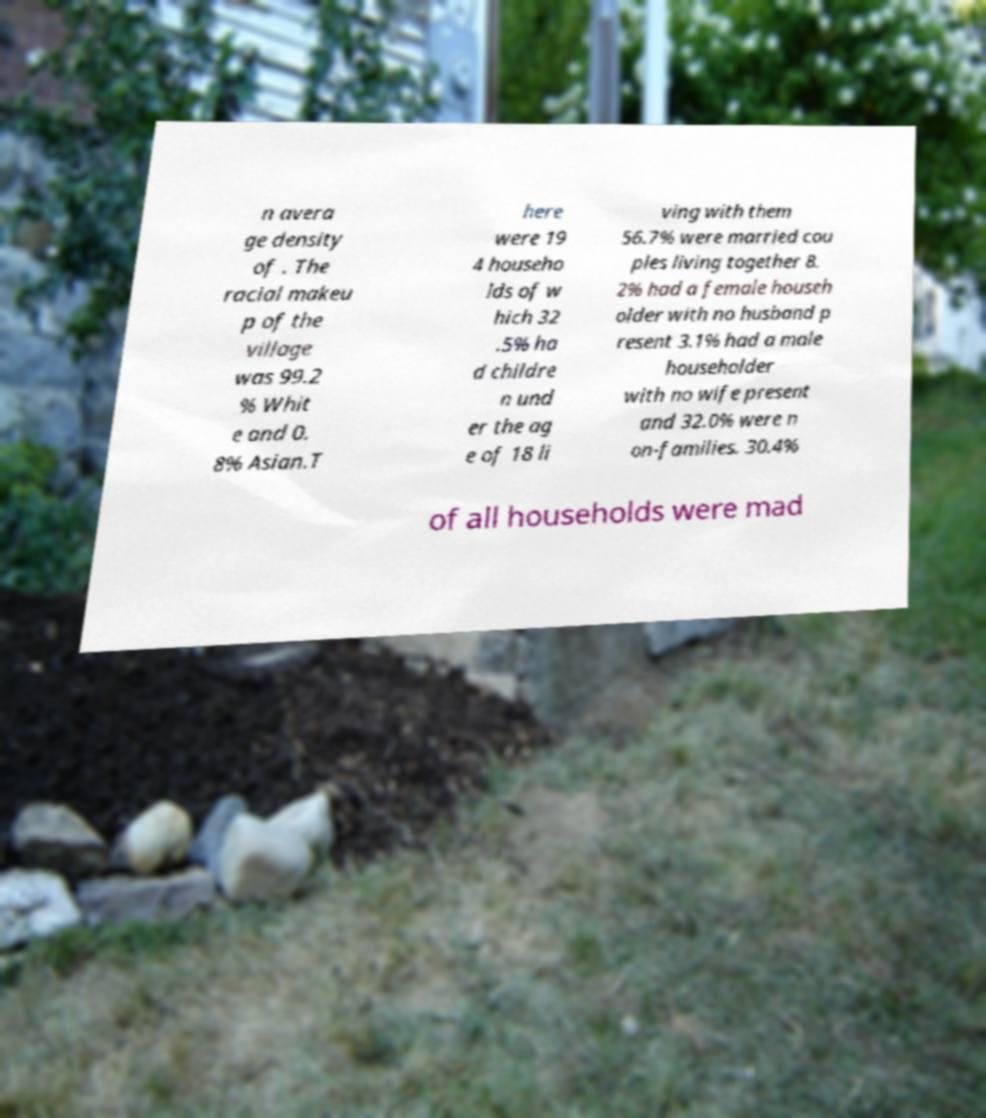I need the written content from this picture converted into text. Can you do that? n avera ge density of . The racial makeu p of the village was 99.2 % Whit e and 0. 8% Asian.T here were 19 4 househo lds of w hich 32 .5% ha d childre n und er the ag e of 18 li ving with them 56.7% were married cou ples living together 8. 2% had a female househ older with no husband p resent 3.1% had a male householder with no wife present and 32.0% were n on-families. 30.4% of all households were mad 